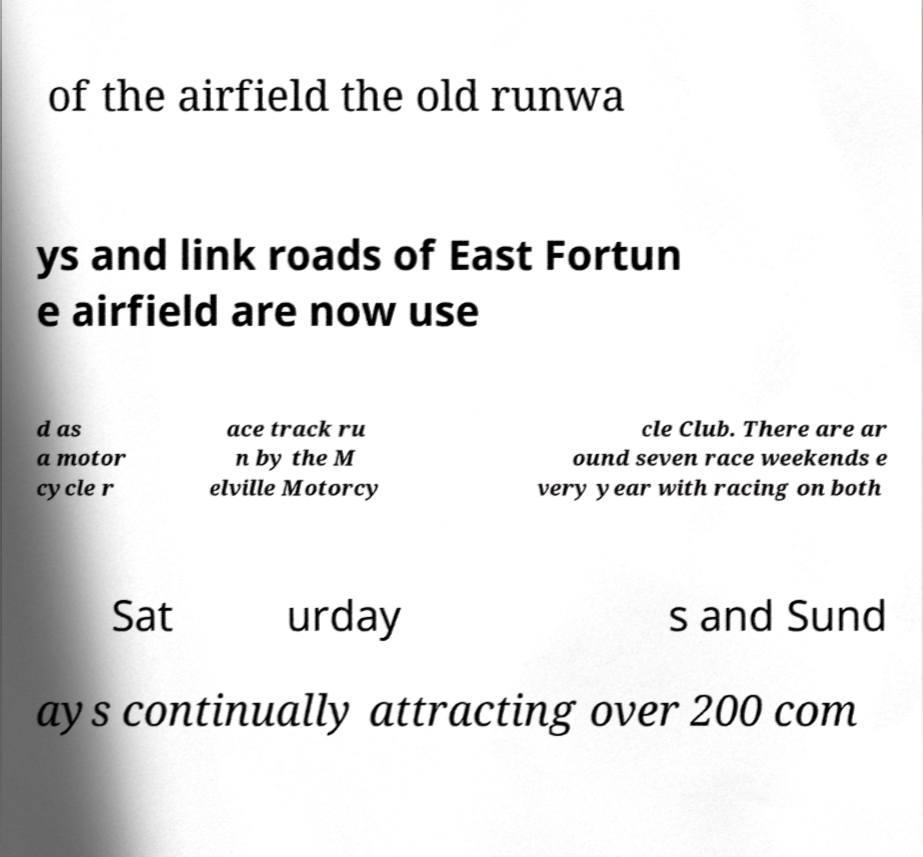Can you read and provide the text displayed in the image?This photo seems to have some interesting text. Can you extract and type it out for me? of the airfield the old runwa ys and link roads of East Fortun e airfield are now use d as a motor cycle r ace track ru n by the M elville Motorcy cle Club. There are ar ound seven race weekends e very year with racing on both Sat urday s and Sund ays continually attracting over 200 com 